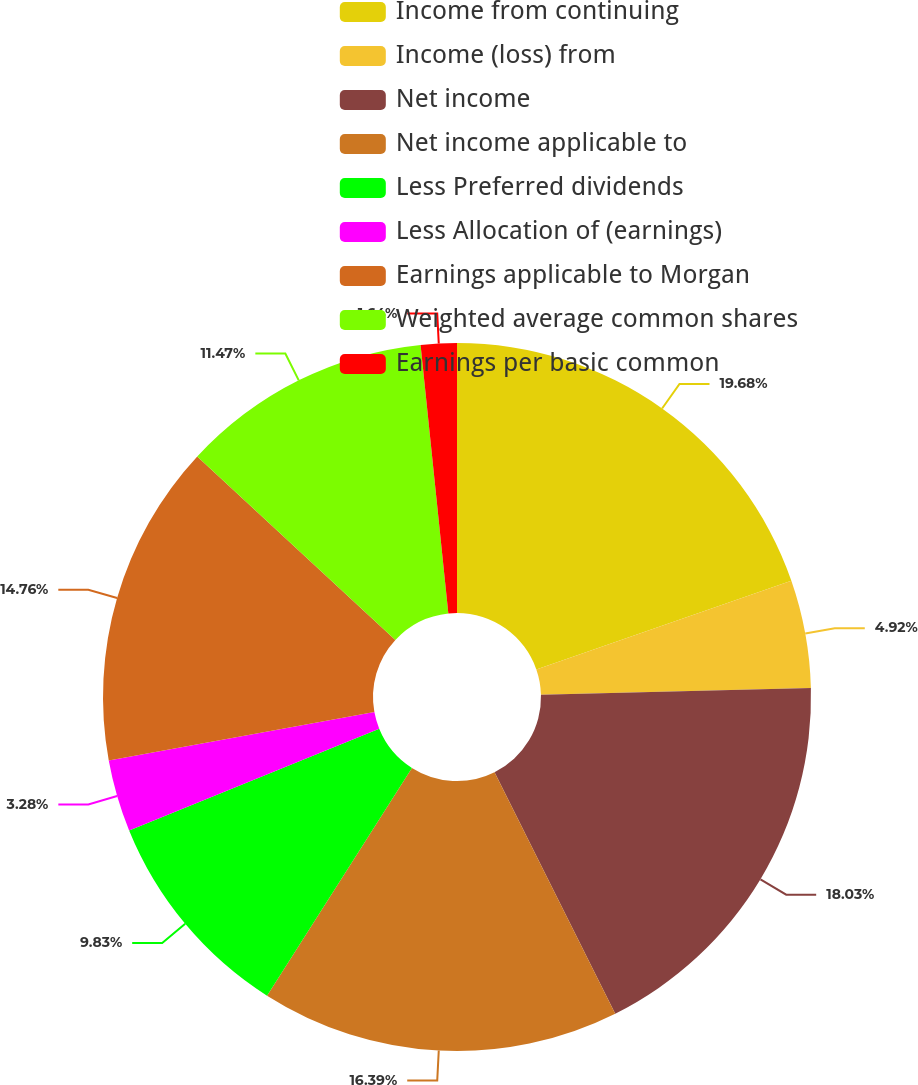<chart> <loc_0><loc_0><loc_500><loc_500><pie_chart><fcel>Income from continuing<fcel>Income (loss) from<fcel>Net income<fcel>Net income applicable to<fcel>Less Preferred dividends<fcel>Less Allocation of (earnings)<fcel>Earnings applicable to Morgan<fcel>Weighted average common shares<fcel>Earnings per basic common<nl><fcel>19.67%<fcel>4.92%<fcel>18.03%<fcel>16.39%<fcel>9.83%<fcel>3.28%<fcel>14.76%<fcel>11.47%<fcel>1.64%<nl></chart> 